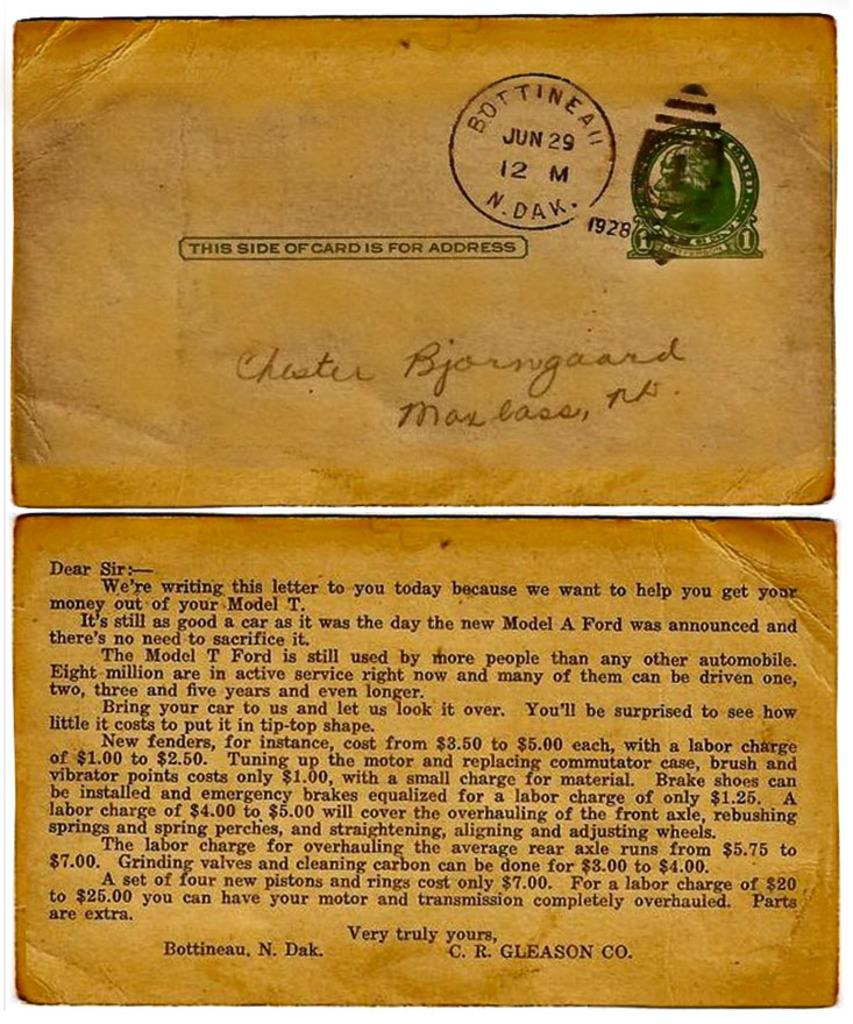Provide a one-sentence caption for the provided image. A old letter that is stapped Bottinea jun 29 12 N Dak. 